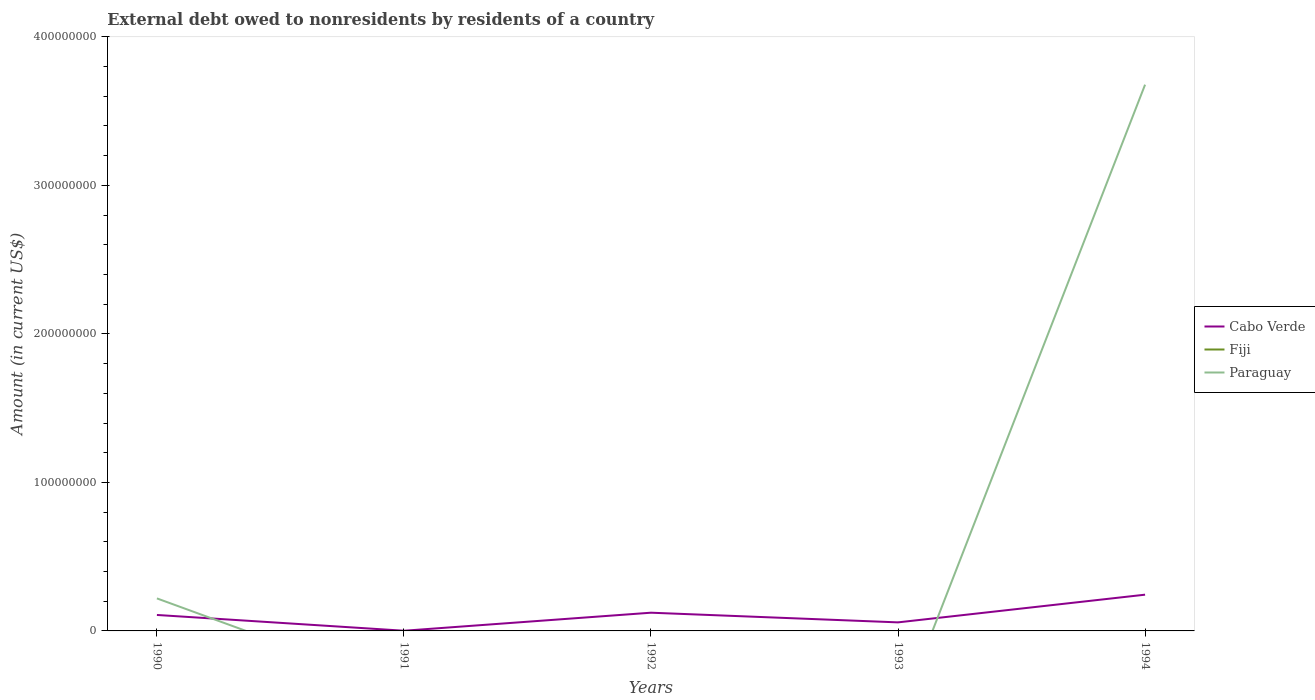How many different coloured lines are there?
Make the answer very short. 2. Is the number of lines equal to the number of legend labels?
Make the answer very short. No. Across all years, what is the maximum external debt owed by residents in Fiji?
Make the answer very short. 0. What is the total external debt owed by residents in Cabo Verde in the graph?
Provide a short and direct response. -1.86e+07. What is the difference between the highest and the second highest external debt owed by residents in Cabo Verde?
Keep it short and to the point. 2.43e+07. How many years are there in the graph?
Provide a short and direct response. 5. What is the difference between two consecutive major ticks on the Y-axis?
Your answer should be compact. 1.00e+08. Are the values on the major ticks of Y-axis written in scientific E-notation?
Make the answer very short. No. Does the graph contain any zero values?
Make the answer very short. Yes. Where does the legend appear in the graph?
Your answer should be very brief. Center right. How many legend labels are there?
Give a very brief answer. 3. How are the legend labels stacked?
Provide a succinct answer. Vertical. What is the title of the graph?
Provide a succinct answer. External debt owed to nonresidents by residents of a country. What is the Amount (in current US$) in Cabo Verde in 1990?
Offer a very short reply. 1.07e+07. What is the Amount (in current US$) in Fiji in 1990?
Offer a very short reply. 0. What is the Amount (in current US$) of Paraguay in 1990?
Keep it short and to the point. 2.19e+07. What is the Amount (in current US$) in Cabo Verde in 1991?
Keep it short and to the point. 1.22e+05. What is the Amount (in current US$) of Fiji in 1991?
Your answer should be compact. 0. What is the Amount (in current US$) in Paraguay in 1991?
Offer a terse response. 0. What is the Amount (in current US$) of Cabo Verde in 1992?
Offer a very short reply. 1.23e+07. What is the Amount (in current US$) in Cabo Verde in 1993?
Offer a very short reply. 5.76e+06. What is the Amount (in current US$) in Fiji in 1993?
Offer a terse response. 0. What is the Amount (in current US$) in Cabo Verde in 1994?
Give a very brief answer. 2.44e+07. What is the Amount (in current US$) of Fiji in 1994?
Your response must be concise. 0. What is the Amount (in current US$) of Paraguay in 1994?
Your answer should be very brief. 3.68e+08. Across all years, what is the maximum Amount (in current US$) of Cabo Verde?
Your answer should be very brief. 2.44e+07. Across all years, what is the maximum Amount (in current US$) of Paraguay?
Provide a succinct answer. 3.68e+08. Across all years, what is the minimum Amount (in current US$) in Cabo Verde?
Provide a short and direct response. 1.22e+05. What is the total Amount (in current US$) in Cabo Verde in the graph?
Keep it short and to the point. 5.33e+07. What is the total Amount (in current US$) of Fiji in the graph?
Make the answer very short. 0. What is the total Amount (in current US$) in Paraguay in the graph?
Offer a very short reply. 3.90e+08. What is the difference between the Amount (in current US$) in Cabo Verde in 1990 and that in 1991?
Provide a short and direct response. 1.06e+07. What is the difference between the Amount (in current US$) in Cabo Verde in 1990 and that in 1992?
Ensure brevity in your answer.  -1.52e+06. What is the difference between the Amount (in current US$) of Cabo Verde in 1990 and that in 1993?
Your answer should be very brief. 4.99e+06. What is the difference between the Amount (in current US$) of Cabo Verde in 1990 and that in 1994?
Keep it short and to the point. -1.37e+07. What is the difference between the Amount (in current US$) in Paraguay in 1990 and that in 1994?
Your answer should be compact. -3.46e+08. What is the difference between the Amount (in current US$) of Cabo Verde in 1991 and that in 1992?
Ensure brevity in your answer.  -1.21e+07. What is the difference between the Amount (in current US$) in Cabo Verde in 1991 and that in 1993?
Keep it short and to the point. -5.64e+06. What is the difference between the Amount (in current US$) in Cabo Verde in 1991 and that in 1994?
Give a very brief answer. -2.43e+07. What is the difference between the Amount (in current US$) of Cabo Verde in 1992 and that in 1993?
Provide a short and direct response. 6.51e+06. What is the difference between the Amount (in current US$) in Cabo Verde in 1992 and that in 1994?
Your response must be concise. -1.21e+07. What is the difference between the Amount (in current US$) in Cabo Verde in 1993 and that in 1994?
Provide a short and direct response. -1.86e+07. What is the difference between the Amount (in current US$) of Cabo Verde in 1990 and the Amount (in current US$) of Paraguay in 1994?
Make the answer very short. -3.57e+08. What is the difference between the Amount (in current US$) of Cabo Verde in 1991 and the Amount (in current US$) of Paraguay in 1994?
Your answer should be very brief. -3.68e+08. What is the difference between the Amount (in current US$) in Cabo Verde in 1992 and the Amount (in current US$) in Paraguay in 1994?
Offer a terse response. -3.56e+08. What is the difference between the Amount (in current US$) of Cabo Verde in 1993 and the Amount (in current US$) of Paraguay in 1994?
Keep it short and to the point. -3.62e+08. What is the average Amount (in current US$) in Cabo Verde per year?
Your answer should be compact. 1.07e+07. What is the average Amount (in current US$) in Fiji per year?
Give a very brief answer. 0. What is the average Amount (in current US$) of Paraguay per year?
Offer a very short reply. 7.79e+07. In the year 1990, what is the difference between the Amount (in current US$) of Cabo Verde and Amount (in current US$) of Paraguay?
Provide a short and direct response. -1.12e+07. In the year 1994, what is the difference between the Amount (in current US$) of Cabo Verde and Amount (in current US$) of Paraguay?
Provide a short and direct response. -3.43e+08. What is the ratio of the Amount (in current US$) in Cabo Verde in 1990 to that in 1991?
Give a very brief answer. 88.08. What is the ratio of the Amount (in current US$) in Cabo Verde in 1990 to that in 1992?
Provide a succinct answer. 0.88. What is the ratio of the Amount (in current US$) of Cabo Verde in 1990 to that in 1993?
Give a very brief answer. 1.87. What is the ratio of the Amount (in current US$) in Cabo Verde in 1990 to that in 1994?
Your answer should be very brief. 0.44. What is the ratio of the Amount (in current US$) of Paraguay in 1990 to that in 1994?
Offer a very short reply. 0.06. What is the ratio of the Amount (in current US$) in Cabo Verde in 1991 to that in 1992?
Offer a terse response. 0.01. What is the ratio of the Amount (in current US$) in Cabo Verde in 1991 to that in 1993?
Offer a very short reply. 0.02. What is the ratio of the Amount (in current US$) in Cabo Verde in 1991 to that in 1994?
Provide a short and direct response. 0.01. What is the ratio of the Amount (in current US$) of Cabo Verde in 1992 to that in 1993?
Offer a terse response. 2.13. What is the ratio of the Amount (in current US$) of Cabo Verde in 1992 to that in 1994?
Make the answer very short. 0.5. What is the ratio of the Amount (in current US$) in Cabo Verde in 1993 to that in 1994?
Your answer should be compact. 0.24. What is the difference between the highest and the second highest Amount (in current US$) of Cabo Verde?
Your response must be concise. 1.21e+07. What is the difference between the highest and the lowest Amount (in current US$) in Cabo Verde?
Keep it short and to the point. 2.43e+07. What is the difference between the highest and the lowest Amount (in current US$) of Paraguay?
Provide a succinct answer. 3.68e+08. 